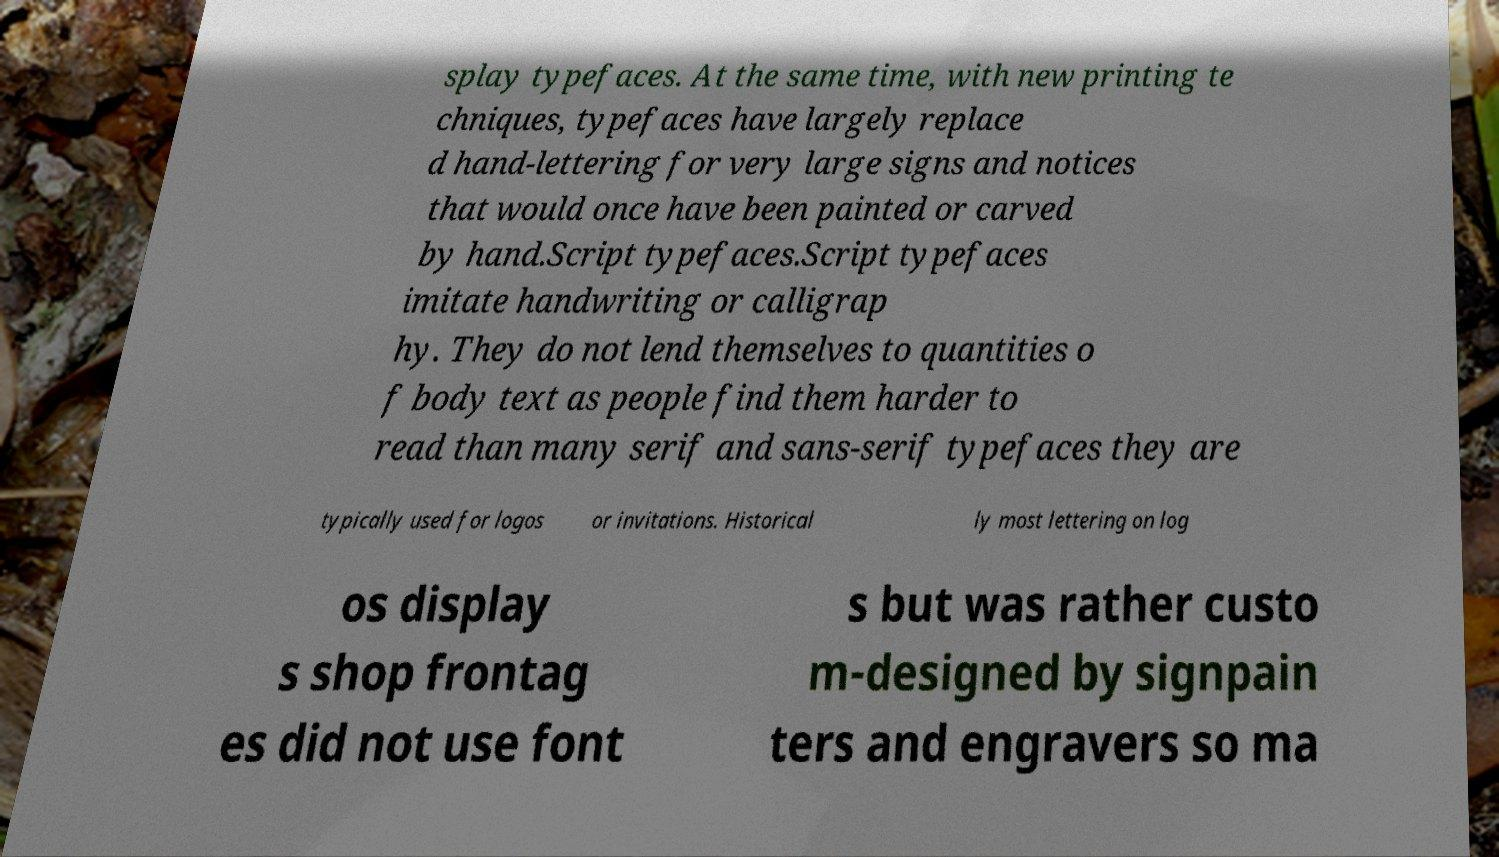Could you assist in decoding the text presented in this image and type it out clearly? splay typefaces. At the same time, with new printing te chniques, typefaces have largely replace d hand-lettering for very large signs and notices that would once have been painted or carved by hand.Script typefaces.Script typefaces imitate handwriting or calligrap hy. They do not lend themselves to quantities o f body text as people find them harder to read than many serif and sans-serif typefaces they are typically used for logos or invitations. Historical ly most lettering on log os display s shop frontag es did not use font s but was rather custo m-designed by signpain ters and engravers so ma 